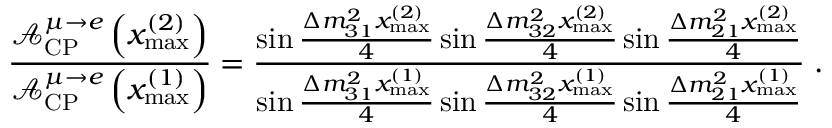Convert formula to latex. <formula><loc_0><loc_0><loc_500><loc_500>\frac { \mathcal { A } _ { C P } ^ { \mu \rightarrow e } \left ( x _ { \max } ^ { ( 2 ) } \right ) } { \mathcal { A } _ { C P } ^ { \mu \rightarrow e } \left ( x _ { \max } ^ { ( 1 ) } \right ) } = \frac { \sin \frac { \Delta m _ { 3 1 } ^ { 2 } x _ { \max } ^ { ( 2 ) } } { 4 } \sin \frac { \Delta m _ { 3 2 } ^ { 2 } x _ { \max } ^ { ( 2 ) } } { 4 } \sin \frac { \Delta m _ { 2 1 } ^ { 2 } x _ { \max } ^ { ( 2 ) } } { 4 } } { \sin \frac { \Delta m _ { 3 1 } ^ { 2 } x _ { \max } ^ { ( 1 ) } } { 4 } \sin \frac { \Delta m _ { 3 2 } ^ { 2 } x _ { \max } ^ { ( 1 ) } } { 4 } \sin \frac { \Delta m _ { 2 1 } ^ { 2 } x _ { \max } ^ { ( 1 ) } } { 4 } } \, .</formula> 